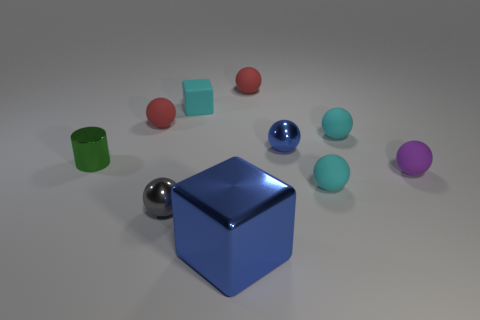Subtract 3 balls. How many balls are left? 4 Subtract all purple balls. How many balls are left? 6 Subtract all small gray balls. How many balls are left? 6 Subtract all cyan balls. Subtract all cyan blocks. How many balls are left? 5 Subtract all blocks. How many objects are left? 8 Add 4 cylinders. How many cylinders exist? 5 Subtract 1 gray spheres. How many objects are left? 9 Subtract all red matte spheres. Subtract all red spheres. How many objects are left? 6 Add 1 cyan matte cubes. How many cyan matte cubes are left? 2 